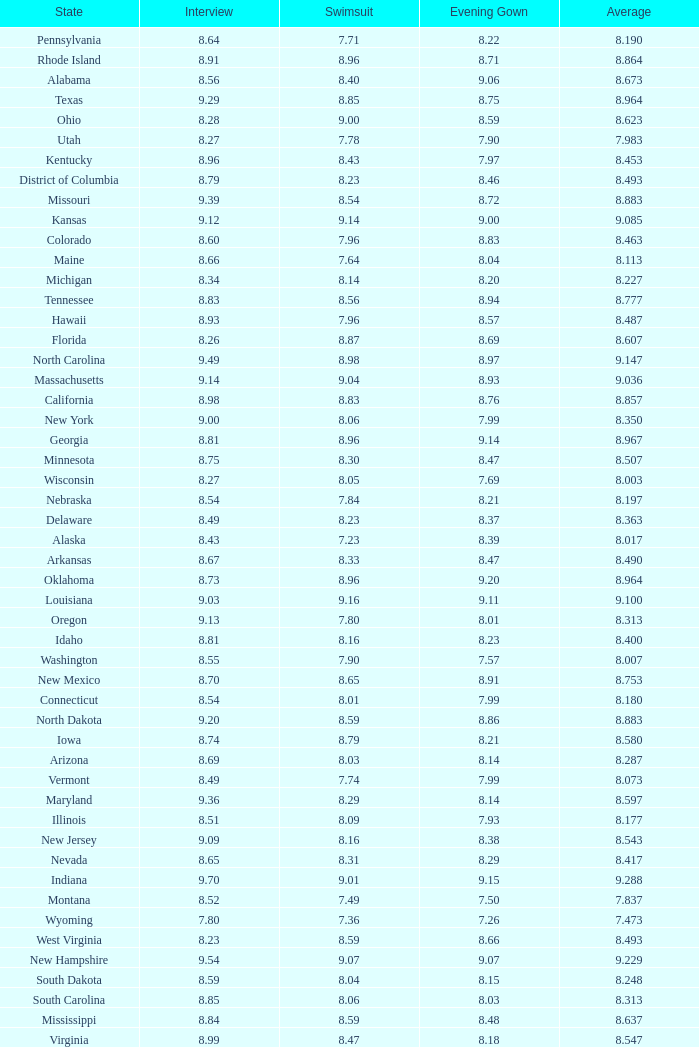Name the state with an evening gown more than 8.86 and interview less than 8.7 and swimsuit less than 8.96 Alabama. 